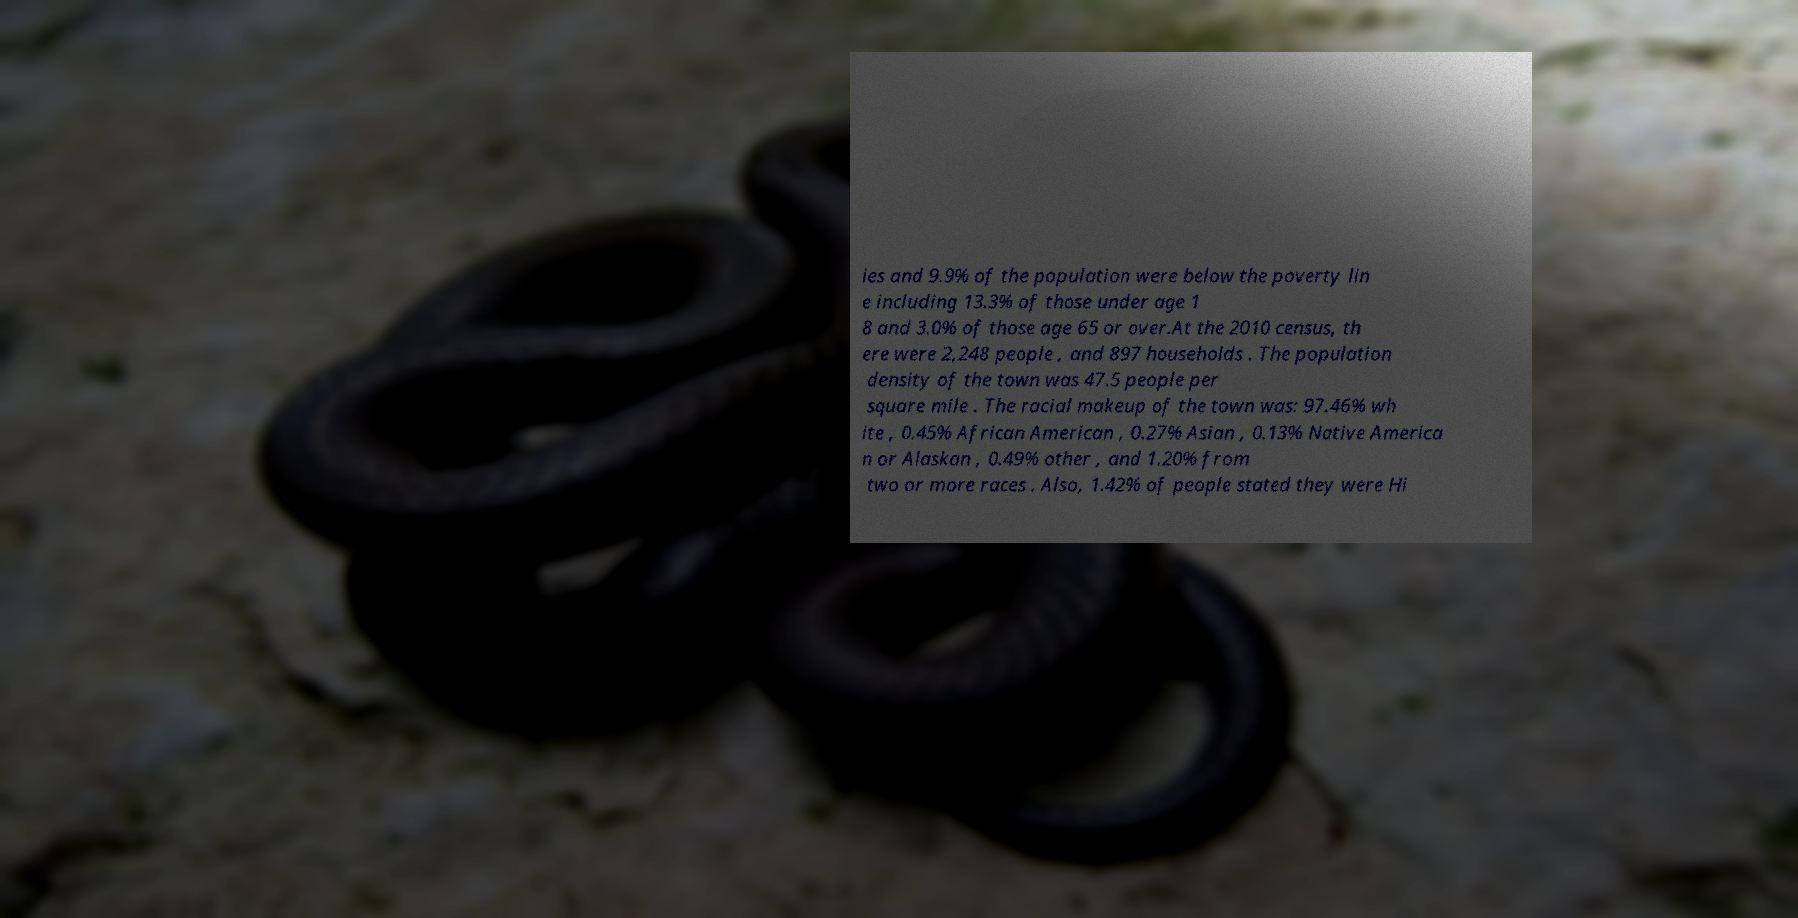Please read and relay the text visible in this image. What does it say? ies and 9.9% of the population were below the poverty lin e including 13.3% of those under age 1 8 and 3.0% of those age 65 or over.At the 2010 census, th ere were 2,248 people , and 897 households . The population density of the town was 47.5 people per square mile . The racial makeup of the town was: 97.46% wh ite , 0.45% African American , 0.27% Asian , 0.13% Native America n or Alaskan , 0.49% other , and 1.20% from two or more races . Also, 1.42% of people stated they were Hi 